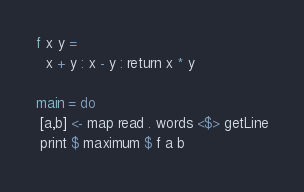<code> <loc_0><loc_0><loc_500><loc_500><_Haskell_>f x y =
  x + y : x - y : return x * y

main = do
 [a,b] <- map read . words <$> getLine
 print $ maximum $ f a b</code> 